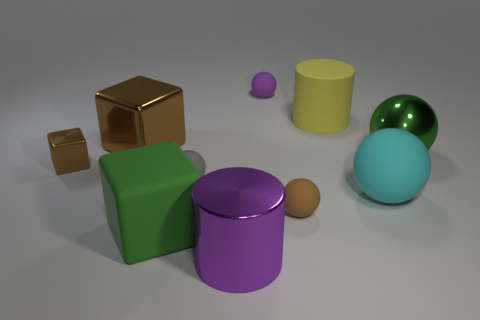How do the colors of the objects relate to each other? The colors of the objects exhibit both contrast and harmony. The blue and green spheres have complementary hues, while the purple cylinder and the yellow container are color opposites, making them stand out. The browns of the cubes are neutral and work well with the other more vivid colors in the scene. 